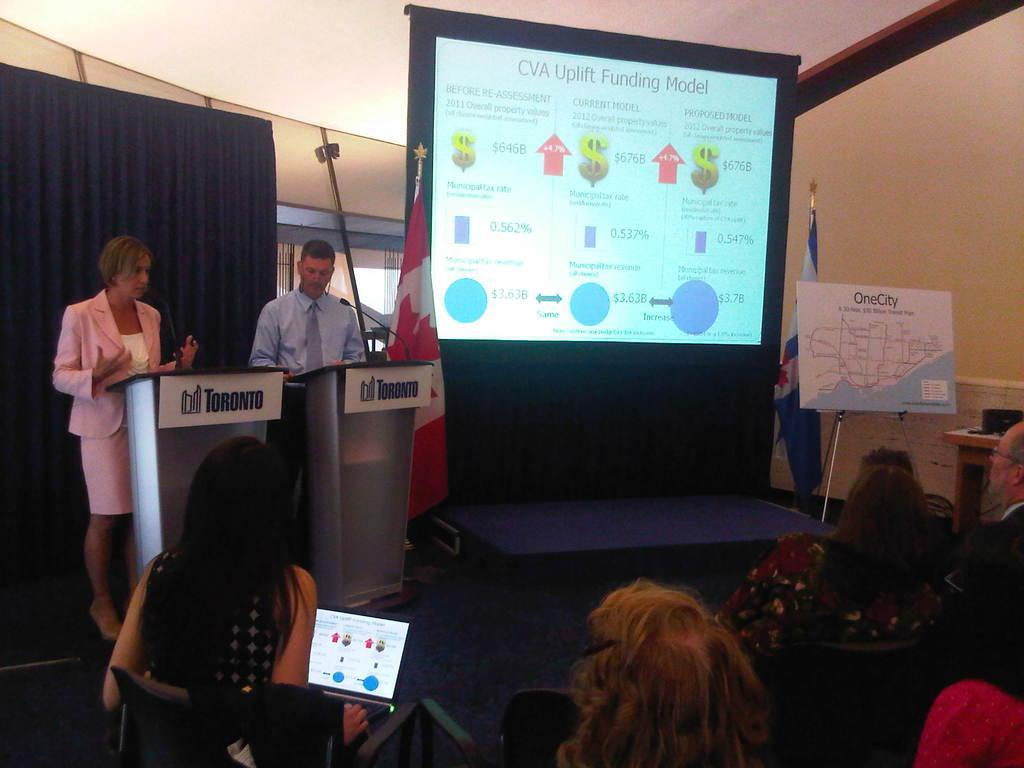Can you describe this image briefly? In this image I can see number of people where in the front I can see few are sitting on chairs and on the right side I can see two of them are standing. I can also see a laptop in the front and on the right side I can see two podiums and on it I can see few mics. In the background I can see a screen, few flags, a board and a curtain. 